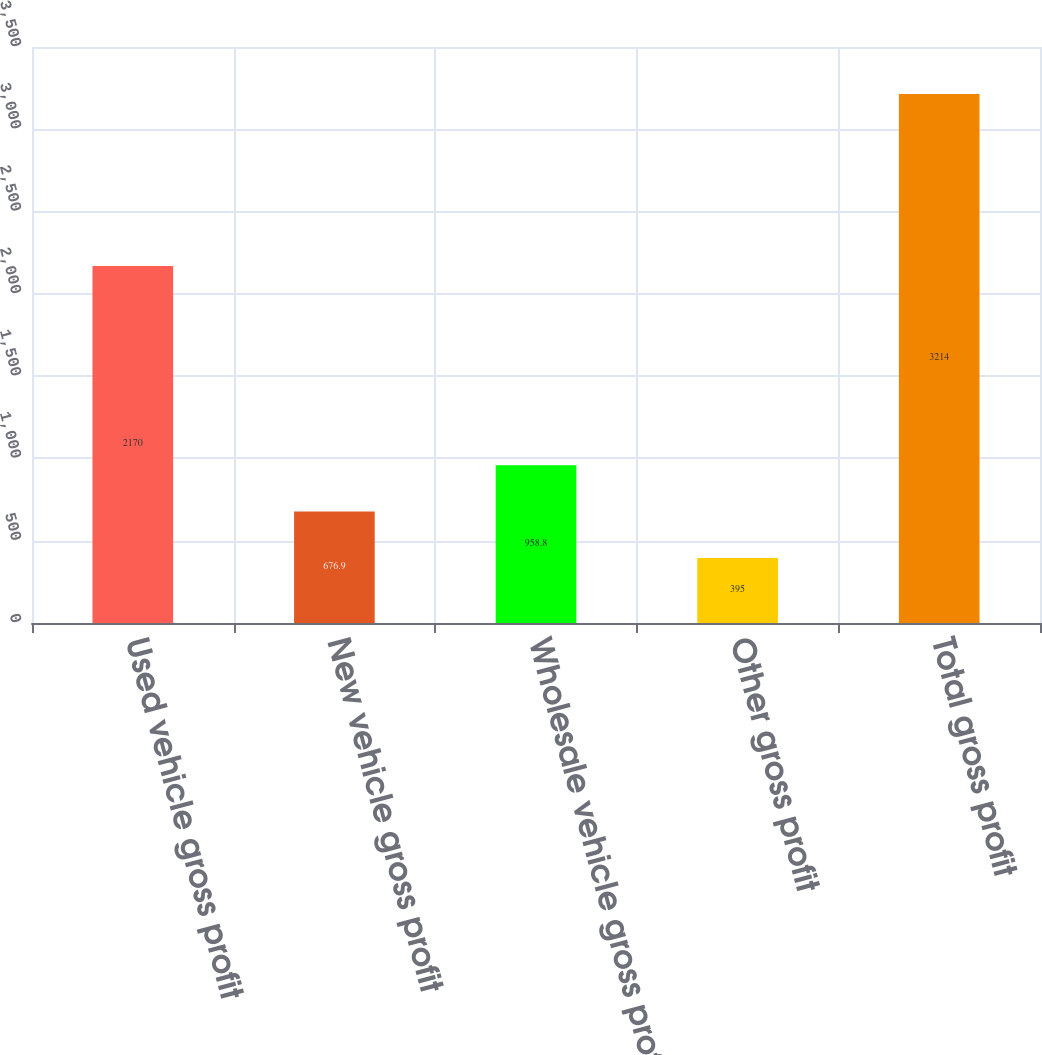<chart> <loc_0><loc_0><loc_500><loc_500><bar_chart><fcel>Used vehicle gross profit<fcel>New vehicle gross profit<fcel>Wholesale vehicle gross profit<fcel>Other gross profit<fcel>Total gross profit<nl><fcel>2170<fcel>676.9<fcel>958.8<fcel>395<fcel>3214<nl></chart> 